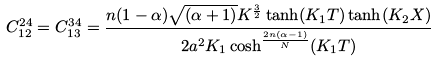<formula> <loc_0><loc_0><loc_500><loc_500>C ^ { 2 4 } _ { 1 2 } = C ^ { 3 4 } _ { 1 3 } = \frac { n ( 1 - \alpha ) \sqrt { ( \alpha + 1 ) } K ^ { \frac { 3 } { 2 } } \tanh ( K _ { 1 } T ) \tanh ( K _ { 2 } X ) } { 2 a ^ { 2 } K _ { 1 } \cosh ^ { \frac { 2 n ( \alpha - 1 ) } { N } } ( K _ { 1 } T ) }</formula> 